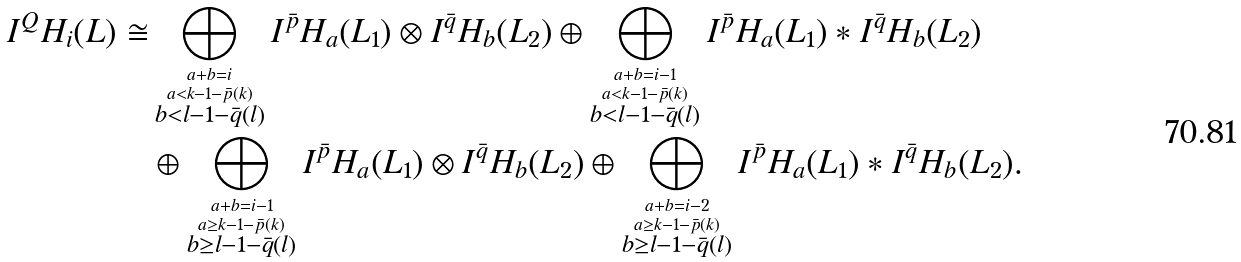<formula> <loc_0><loc_0><loc_500><loc_500>I ^ { Q } H _ { i } ( L ) \cong & \bigoplus _ { \overset { a + b = i } { \overset { a < k - 1 - \bar { p } ( k ) } { b < l - 1 - \bar { q } ( l ) } } } I ^ { \bar { p } } H _ { a } ( L _ { 1 } ) \otimes I ^ { \bar { q } } H _ { b } ( L _ { 2 } ) \oplus \bigoplus _ { \overset { a + b = i - 1 } { \overset { a < k - 1 - \bar { p } ( k ) } { b < l - 1 - \bar { q } ( l ) } } } I ^ { \bar { p } } H _ { a } ( L _ { 1 } ) * I ^ { \bar { q } } H _ { b } ( L _ { 2 } ) \\ & \oplus \bigoplus _ { \overset { a + b = i - 1 } { \overset { a \geq k - 1 - \bar { p } ( k ) } { b \geq l - 1 - \bar { q } ( l ) } } } I ^ { \bar { p } } H _ { a } ( L _ { 1 } ) \otimes I ^ { \bar { q } } H _ { b } ( L _ { 2 } ) \oplus \bigoplus _ { \overset { a + b = i - 2 } { \overset { a \geq k - 1 - \bar { p } ( k ) } { b \geq l - 1 - \bar { q } ( l ) } } } I ^ { \bar { p } } H _ { a } ( L _ { 1 } ) * I ^ { \bar { q } } H _ { b } ( L _ { 2 } ) .</formula> 